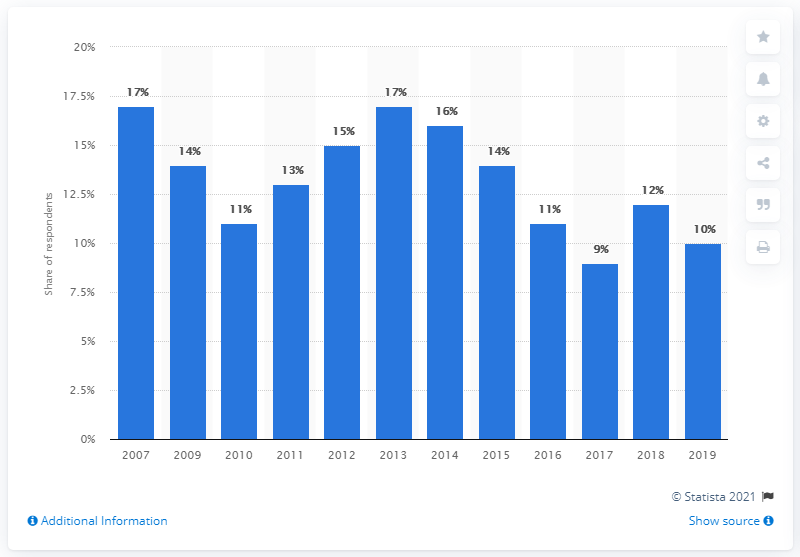Give some essential details in this illustration. According to data from a year earlier, the percentage of people who played games on a computer was 12.. In 2019, the percentage of people playing games on a computer in the UK was approximately 10 percent. 